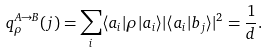<formula> <loc_0><loc_0><loc_500><loc_500>q _ { \rho } ^ { A \rightarrow B } ( j ) = \sum _ { i } \langle a _ { i } | \rho | a _ { i } \rangle | \langle a _ { i } | b _ { j } \rangle | ^ { 2 } = \frac { 1 } { d } .</formula> 